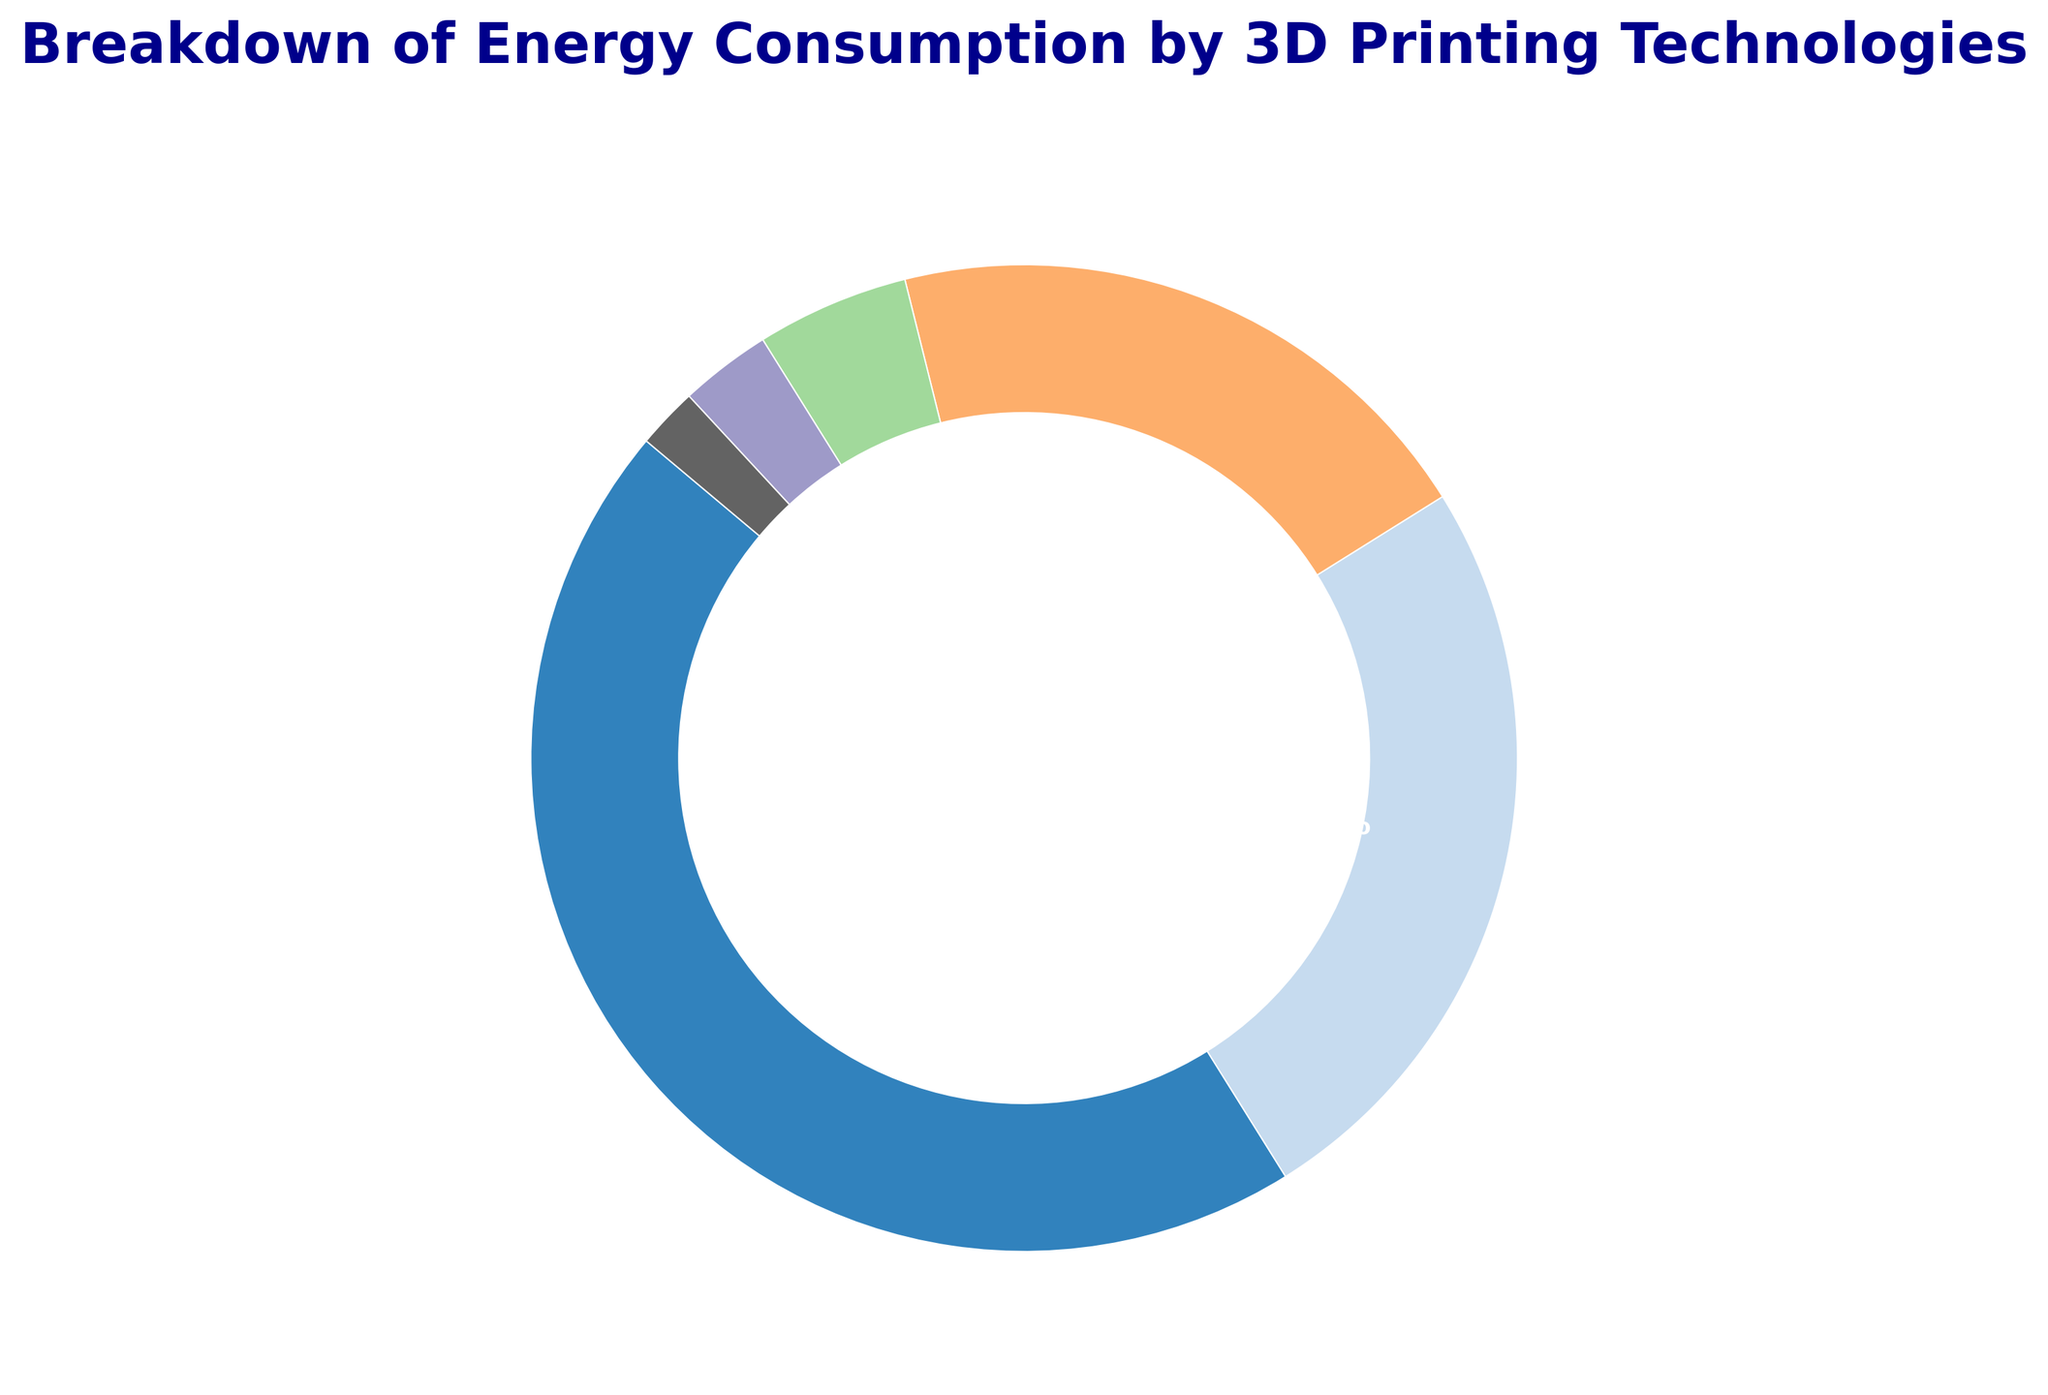Which 3D printing technology has the highest energy consumption percentage? To find the technology with the highest energy consumption, look at the portion of the ring chart with the largest size. The FDM section is the largest, with 45%.
Answer: FDM Which 3D printing technologies collectively consume 50% of the total energy? To determine this, combine the percentages of the different segments until they sum to 50%. Adding SLA at 25% and SLS at 20% totals 45%, and adding DLP at 5% reaches 50%.
Answer: SLA, SLS, DLP What is the difference in energy consumption between FDM and SLA? Subtract the percentage of SLA from FDM to find the difference. FDM is 45%, and SLA is 25%, so the difference is 45% - 25% = 20%.
Answer: 20% Which technologies have an energy consumption percentage less than 10%? Identify the technologies with segments smaller than 10%. These are DLP at 5%, PolyJet at 3%, and EBM at 2%.
Answer: DLP, PolyJet, EBM If the energy consumption of SLS were increased by 10%, what would be the new total energy consumption percentage for SLS? Add 10% to the current energy consumption of SLS, which is 20%. The new value would be 20% + 10% = 30%.
Answer: 30% Compare the combined energy consumption of PolyJet and EBM with that of DLP. Which is greater, and by how much? Add the percentages of PolyJet and EBM (3% + 2% = 5%) and compare with DLP (5%). Both sums are equal.
Answer: Equal What proportion of the total energy is consumed by the top two technologies combined? Sum the percentages of the top two technologies, FDM and SLA. FDM is 45%, and SLA is 25%, totaling 45% + 25% = 70%.
Answer: 70% What color is used to represent the FDM technology in the ring chart? Look at the visual representation of the ring chart to identify the color of the largest segment, which is FDM. Assuming the use of plt.cm.tab20c, the color would likely be blue for the first segment.
Answer: Blue 